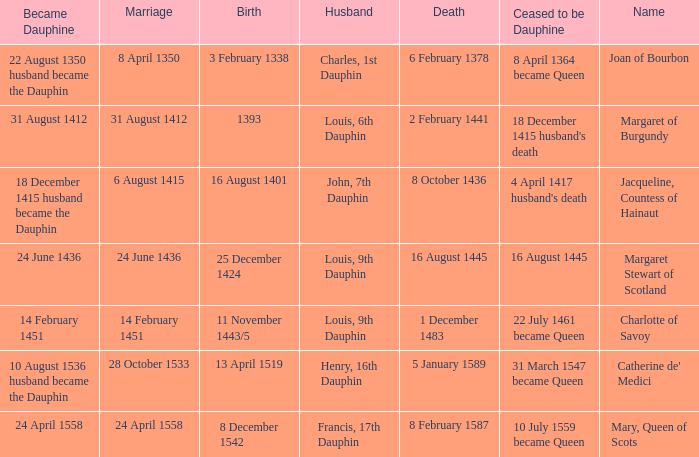Who has a birth of 16 august 1401? Jacqueline, Countess of Hainaut. 